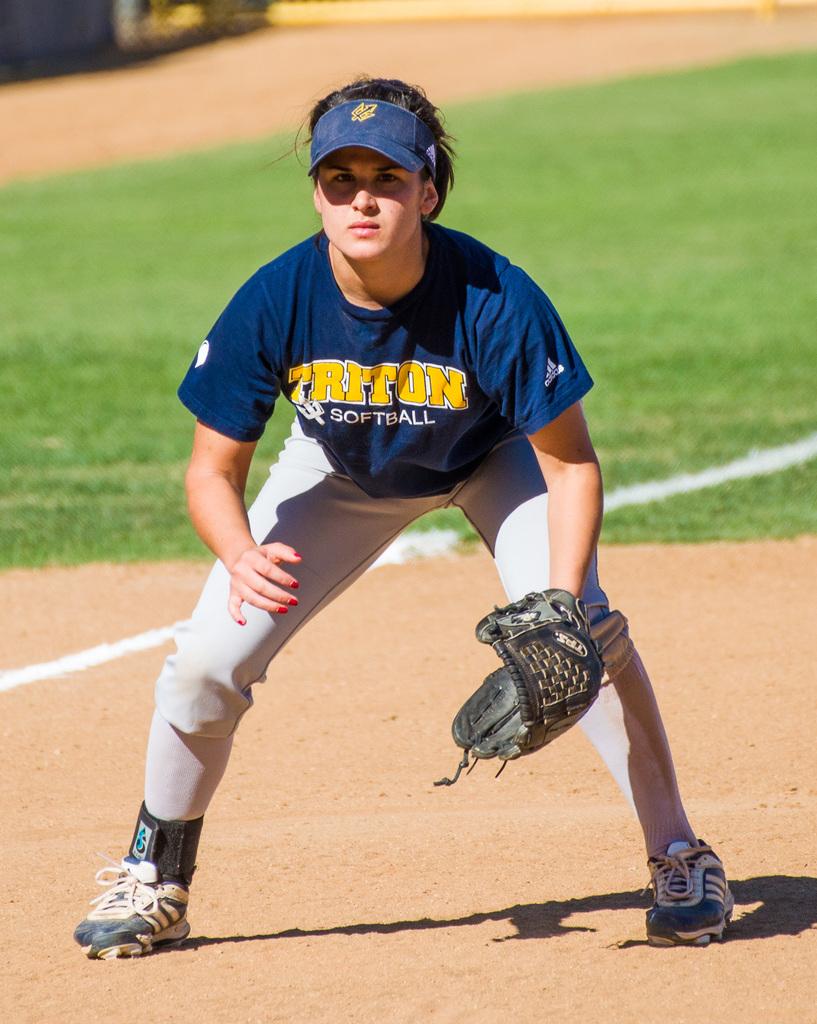What type of league is this team?
Make the answer very short. Softball. What is the team name on the front of the person's jersey?
Keep it short and to the point. Triton. 